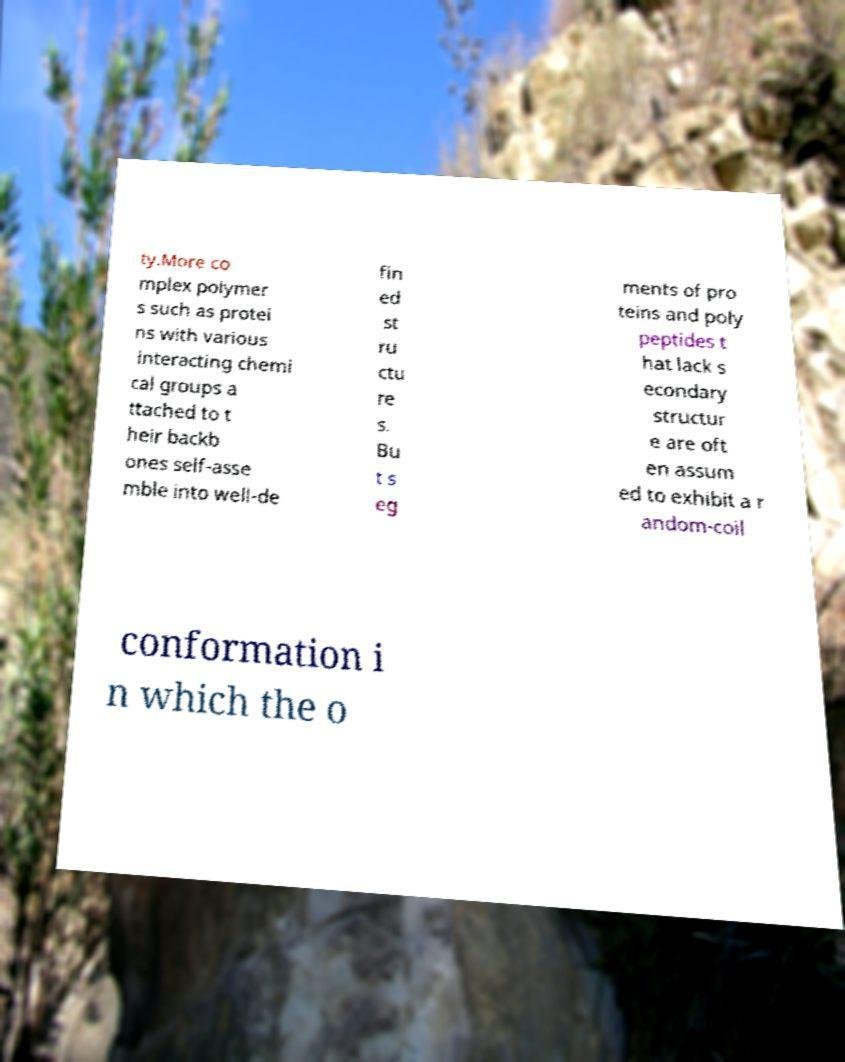For documentation purposes, I need the text within this image transcribed. Could you provide that? ty.More co mplex polymer s such as protei ns with various interacting chemi cal groups a ttached to t heir backb ones self-asse mble into well-de fin ed st ru ctu re s. Bu t s eg ments of pro teins and poly peptides t hat lack s econdary structur e are oft en assum ed to exhibit a r andom-coil conformation i n which the o 